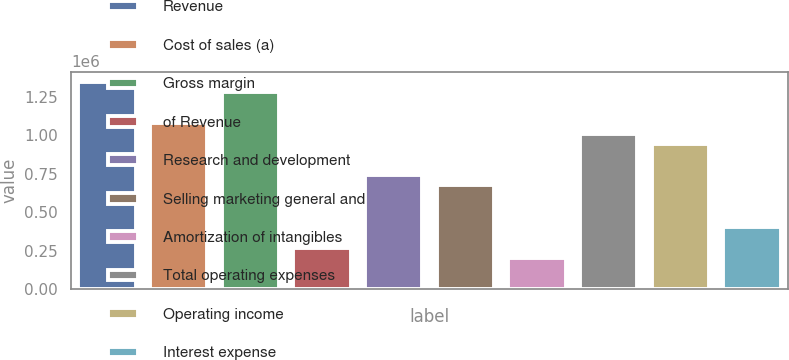Convert chart to OTSL. <chart><loc_0><loc_0><loc_500><loc_500><bar_chart><fcel>Revenue<fcel>Cost of sales (a)<fcel>Gross margin<fcel>of Revenue<fcel>Research and development<fcel>Selling marketing general and<fcel>Amortization of intangibles<fcel>Total operating expenses<fcel>Operating income<fcel>Interest expense<nl><fcel>1.34834e+06<fcel>1.07868e+06<fcel>1.28093e+06<fcel>269669<fcel>741589<fcel>674172<fcel>202252<fcel>1.01126e+06<fcel>943841<fcel>404503<nl></chart> 